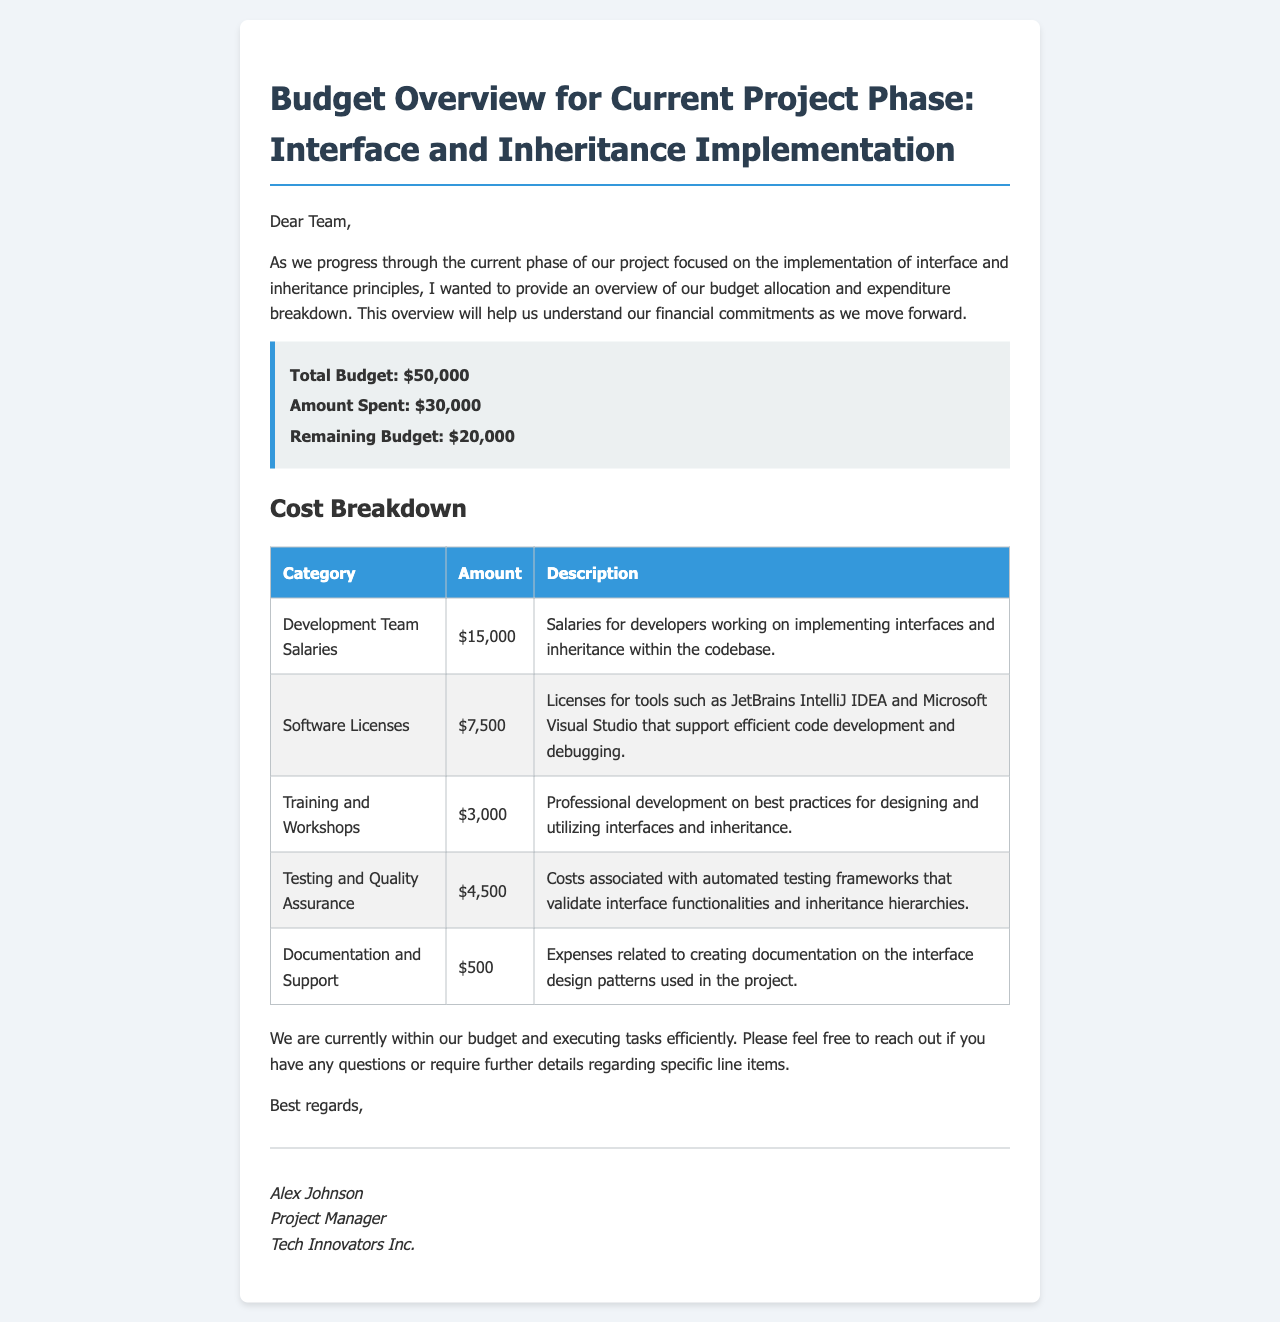What is the total budget? The total budget is explicitly stated in the document summary as $50,000.
Answer: $50,000 How much has been spent? The amount spent is provided in the budget summary section, which shows $30,000.
Answer: $30,000 What is the remaining budget? The remaining budget is calculated by subtracting the amount spent from the total budget, which is mentioned as $20,000.
Answer: $20,000 What category has the highest cost? The highest cost category in the breakdown is identified as Development Team Salaries, with an amount of $15,000.
Answer: Development Team Salaries What does the Software Licenses cost? The document specifies the cost of Software Licenses under the cost breakdown as $7,500.
Answer: $7,500 Which expense is the smallest? The smallest expense listed in the breakdown is Documentation and Support, costing $500.
Answer: $500 What is the purpose of the Training and Workshops expense? The reason provided for the Training and Workshops expense is professional development on best practices.
Answer: Professional development How is the project performing concerning the budget? The document indicates that the project is currently within budget and executing tasks efficiently.
Answer: Within budget Who is the sender of the email? The sender of the email is identified as Alex Johnson, who is the Project Manager.
Answer: Alex Johnson 